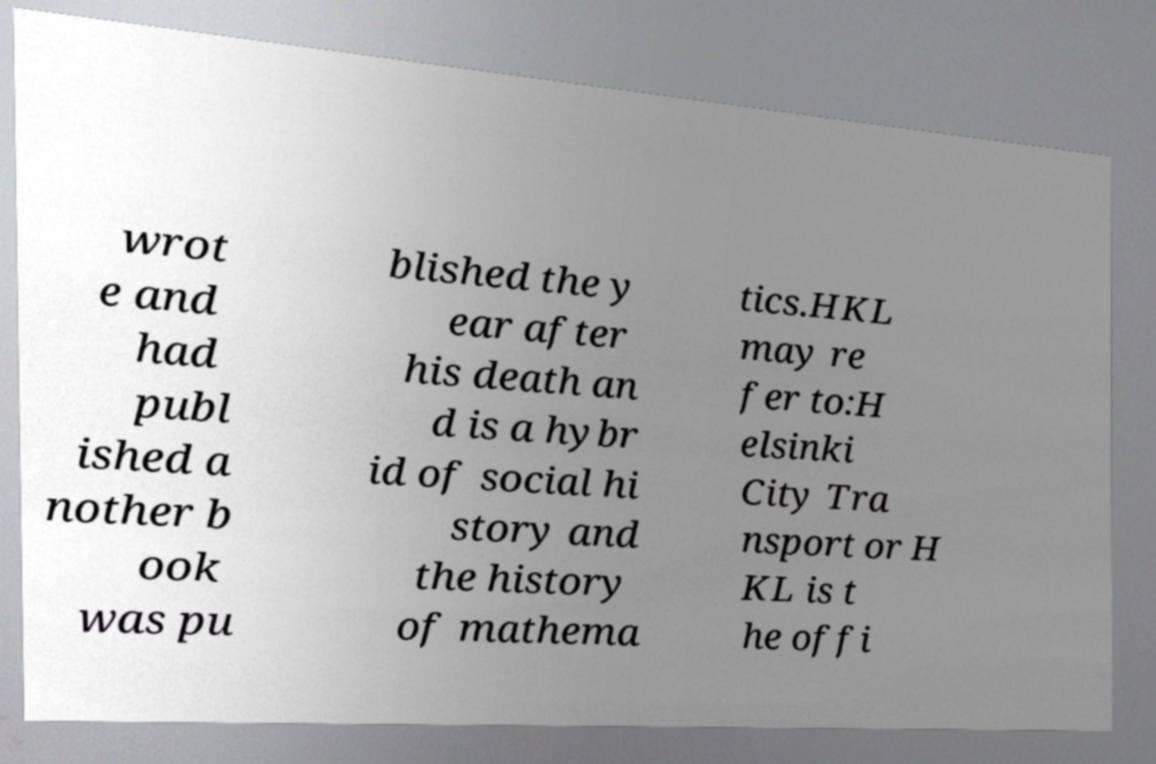Can you read and provide the text displayed in the image?This photo seems to have some interesting text. Can you extract and type it out for me? wrot e and had publ ished a nother b ook was pu blished the y ear after his death an d is a hybr id of social hi story and the history of mathema tics.HKL may re fer to:H elsinki City Tra nsport or H KL is t he offi 